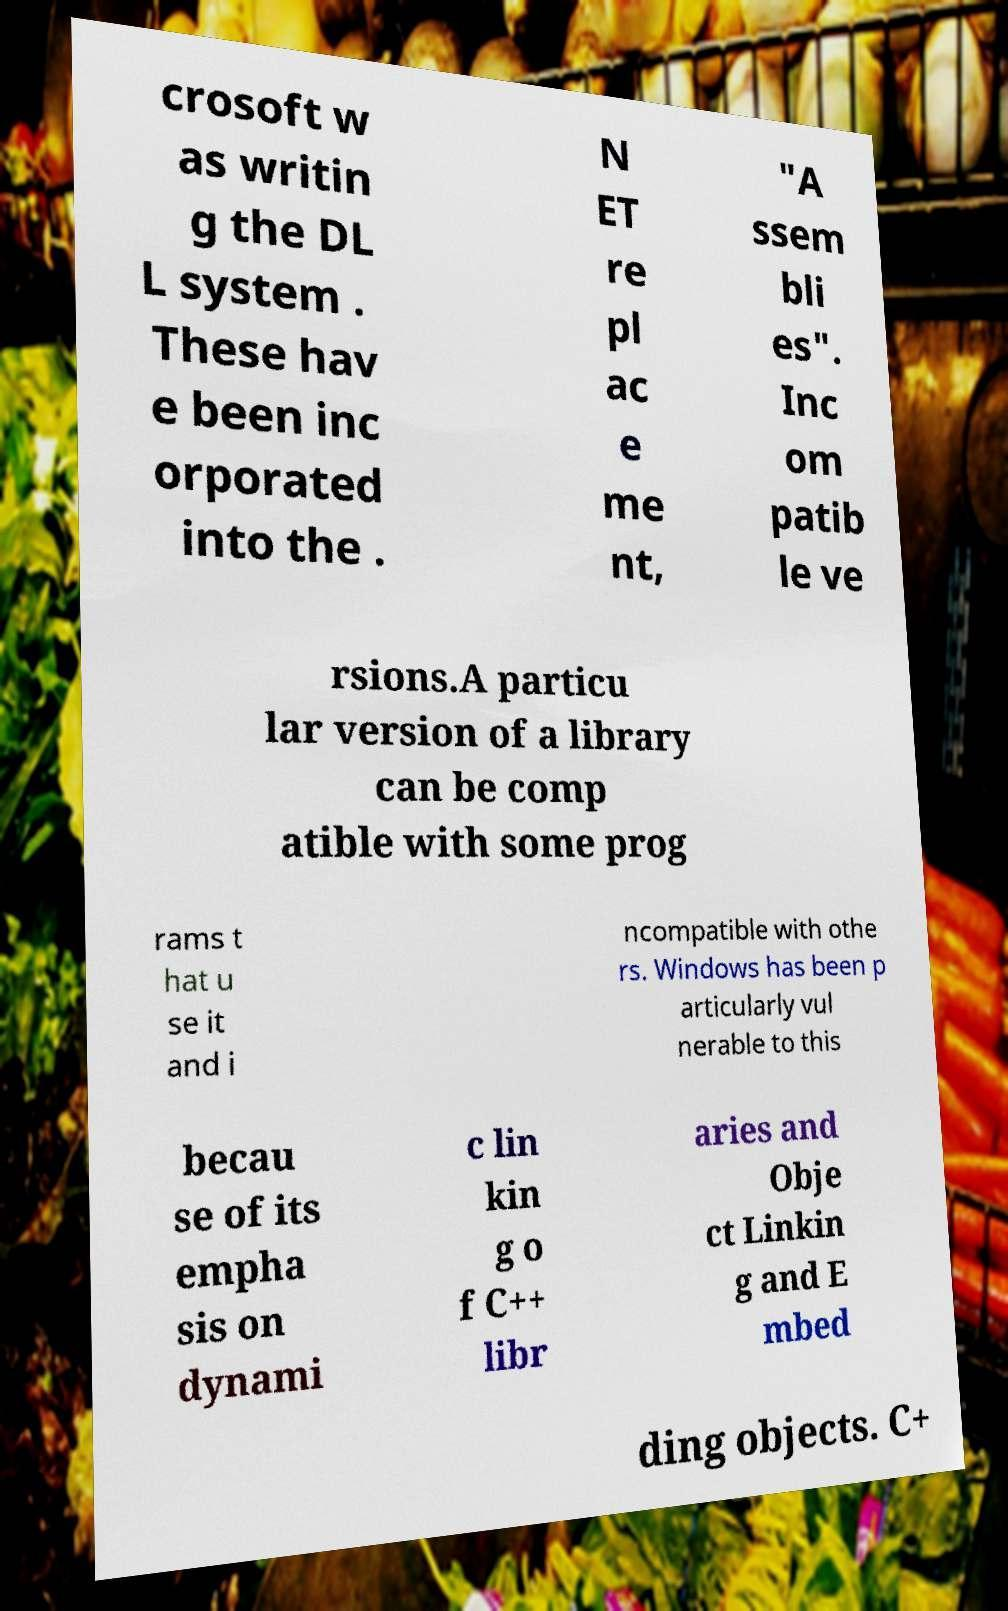Please read and relay the text visible in this image. What does it say? crosoft w as writin g the DL L system . These hav e been inc orporated into the . N ET re pl ac e me nt, "A ssem bli es". Inc om patib le ve rsions.A particu lar version of a library can be comp atible with some prog rams t hat u se it and i ncompatible with othe rs. Windows has been p articularly vul nerable to this becau se of its empha sis on dynami c lin kin g o f C++ libr aries and Obje ct Linkin g and E mbed ding objects. C+ 